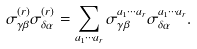<formula> <loc_0><loc_0><loc_500><loc_500>\sigma ^ { ( r ) } _ { \gamma \beta } \sigma ^ { ( r ) } _ { \delta \alpha } = \sum _ { a _ { 1 } \cdots a _ { r } } \sigma ^ { a _ { 1 } \cdots a _ { r } } _ { \gamma \beta } \sigma ^ { a _ { 1 } \cdots a _ { r } } _ { \delta \alpha } .</formula> 